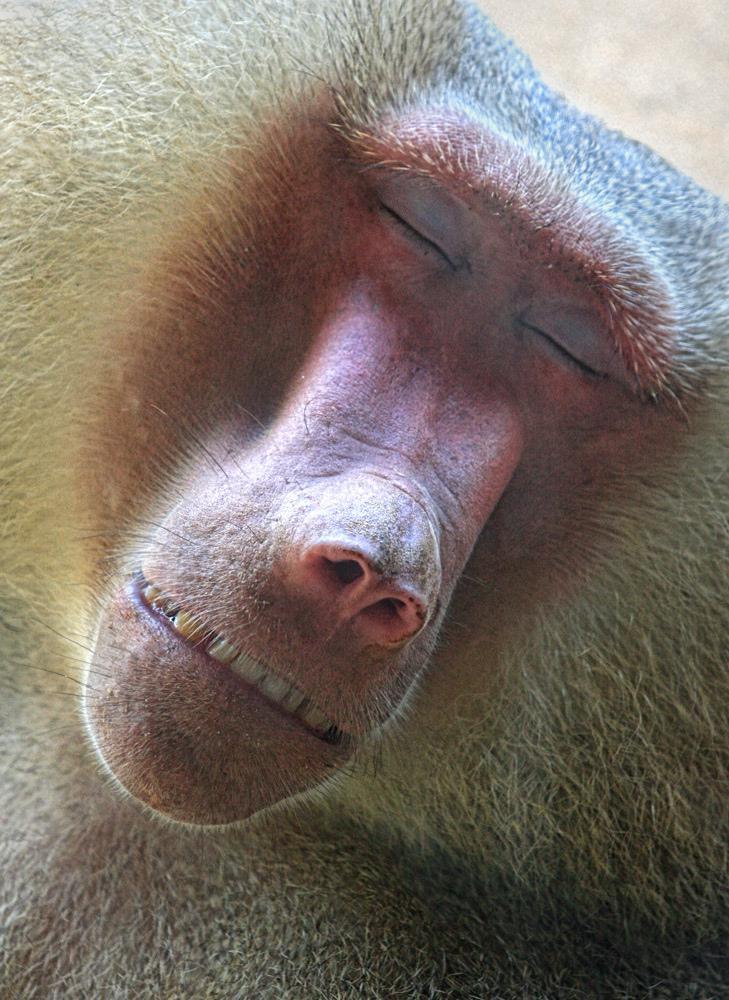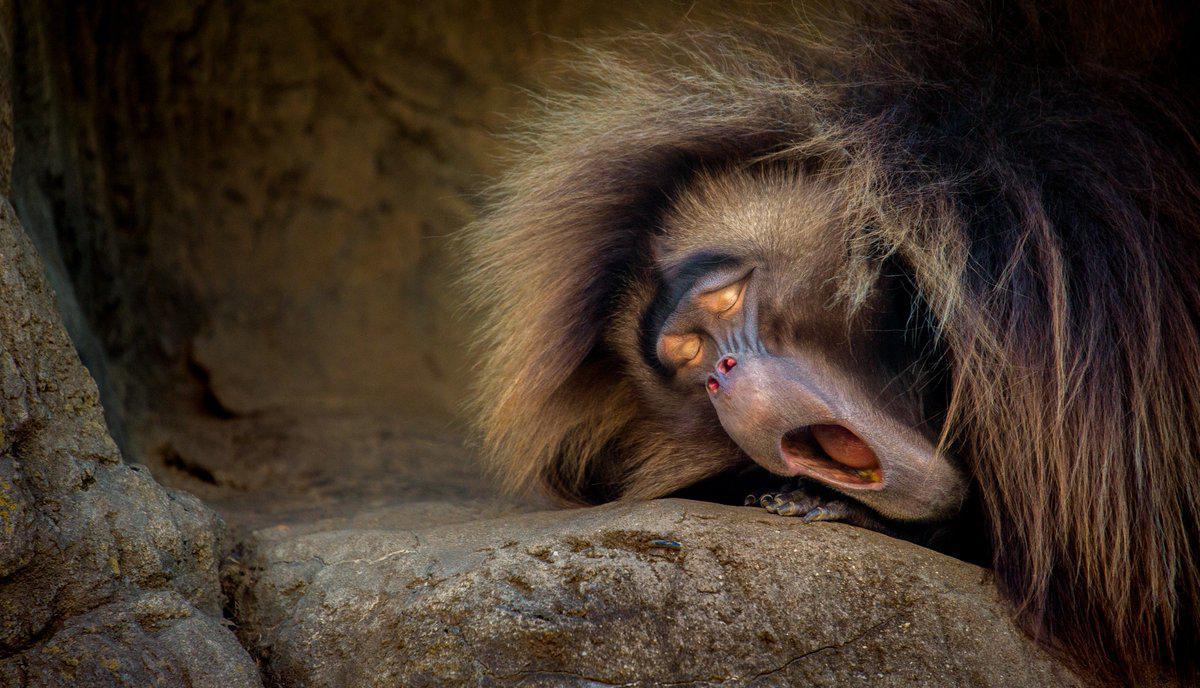The first image is the image on the left, the second image is the image on the right. For the images shown, is this caption "There is a baby monkey in each image." true? Answer yes or no. No. 